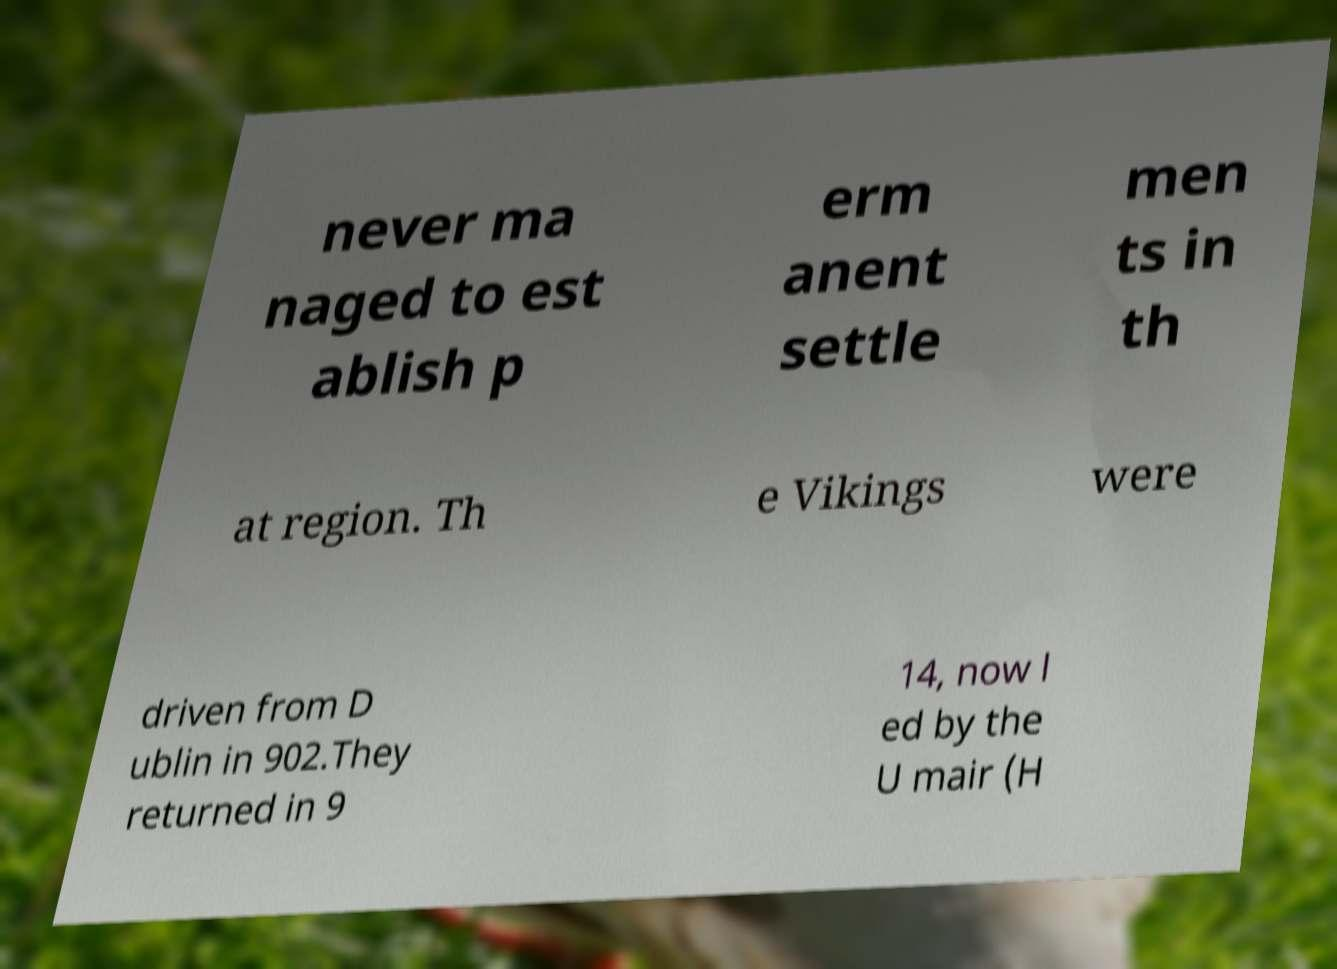Can you accurately transcribe the text from the provided image for me? never ma naged to est ablish p erm anent settle men ts in th at region. Th e Vikings were driven from D ublin in 902.They returned in 9 14, now l ed by the U mair (H 